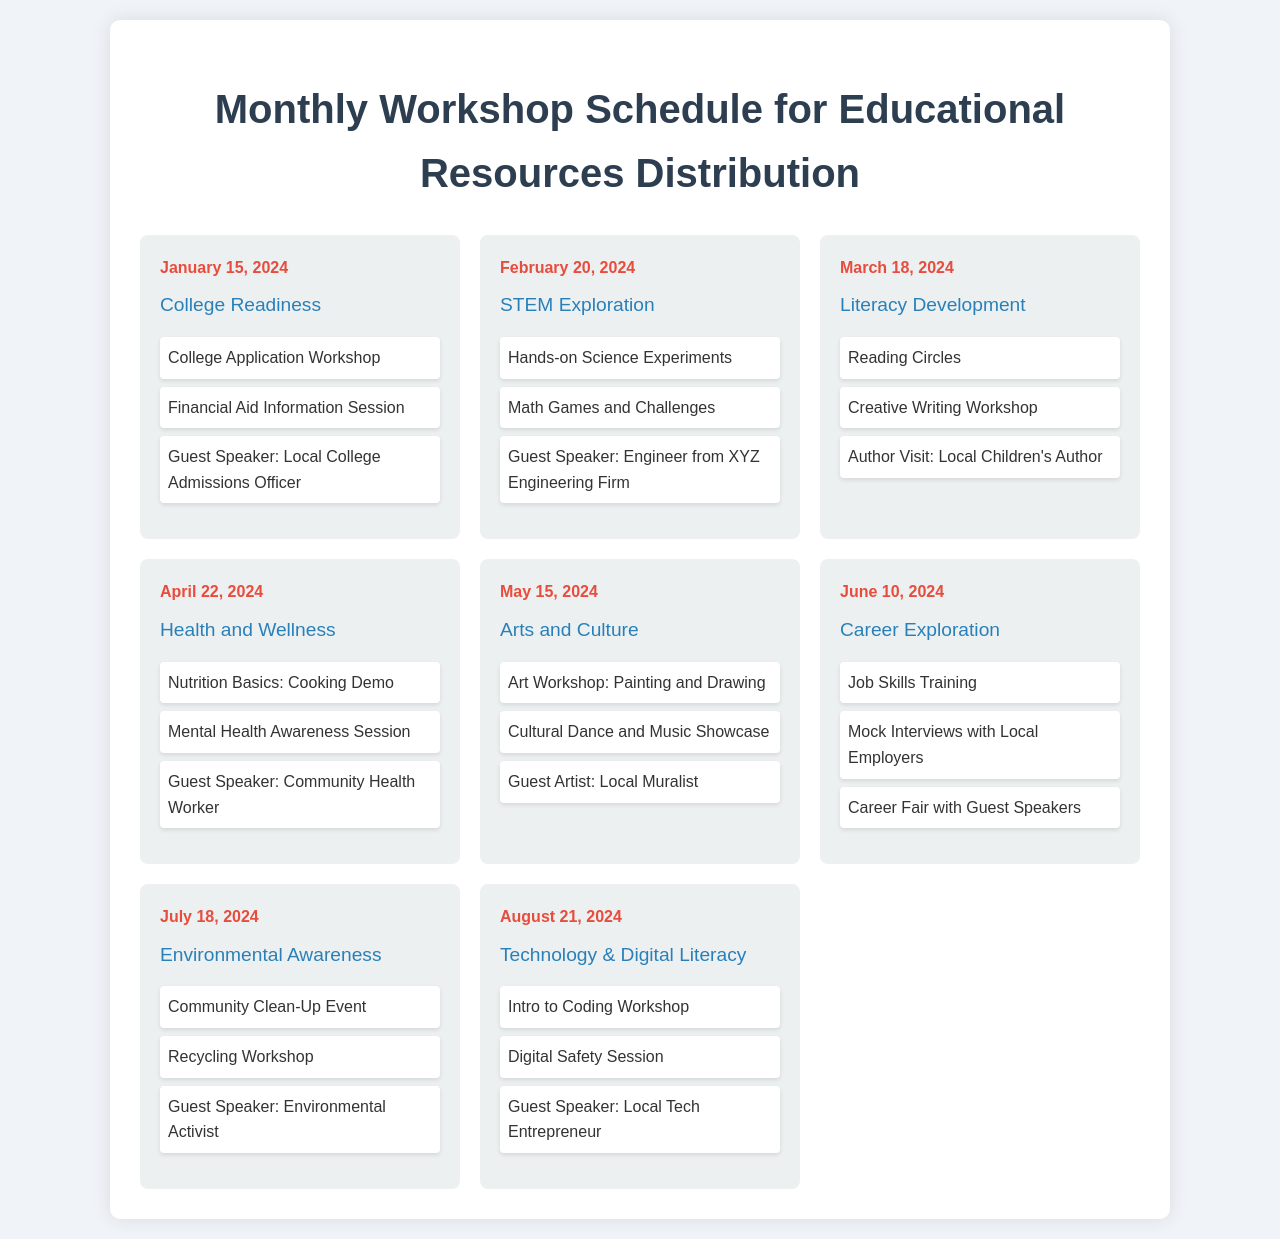What is the date of the College Readiness workshop? The date is specified in the document, which shows that the College Readiness workshop is scheduled for January 15, 2024.
Answer: January 15, 2024 What theme will the workshop on February 20, 2024, cover? The theme for the workshop on February 20, 2024, is stated in the document as STEM Exploration.
Answer: STEM Exploration How many activities are listed for the Health and Wellness workshop? The number of activities is counted in the document for the Health and Wellness workshop, which lists three activities.
Answer: 3 Who will be speaking at the Literacy Development workshop? The guest speaker is outlined in the document for the Literacy Development workshop, which mentions a local children's author.
Answer: Local Children's Author What date is the Environmental Awareness workshop scheduled for? The date for the Environmental Awareness workshop is indicated in the document as July 18, 2024.
Answer: July 18, 2024 Which workshop features a topic on Digital Literacy? The document specifies that the workshop with Digital Literacy is scheduled for August 21, 2024, under the theme Technology & Digital Literacy.
Answer: Technology & Digital Literacy Identify one activity included in the College Readiness workshop. The document lists activities for the College Readiness workshop, where one of the activities is a College Application Workshop.
Answer: College Application Workshop How many workshops are scheduled for the first half of the year? The document contains a total of six workshops scheduled from January to June 2024, indicating them specifically.
Answer: 6 What is the theme for the workshop on May 15, 2024? The theme for the workshop on May 15, 2024, is mentioned in the document as Arts and Culture.
Answer: Arts and Culture 